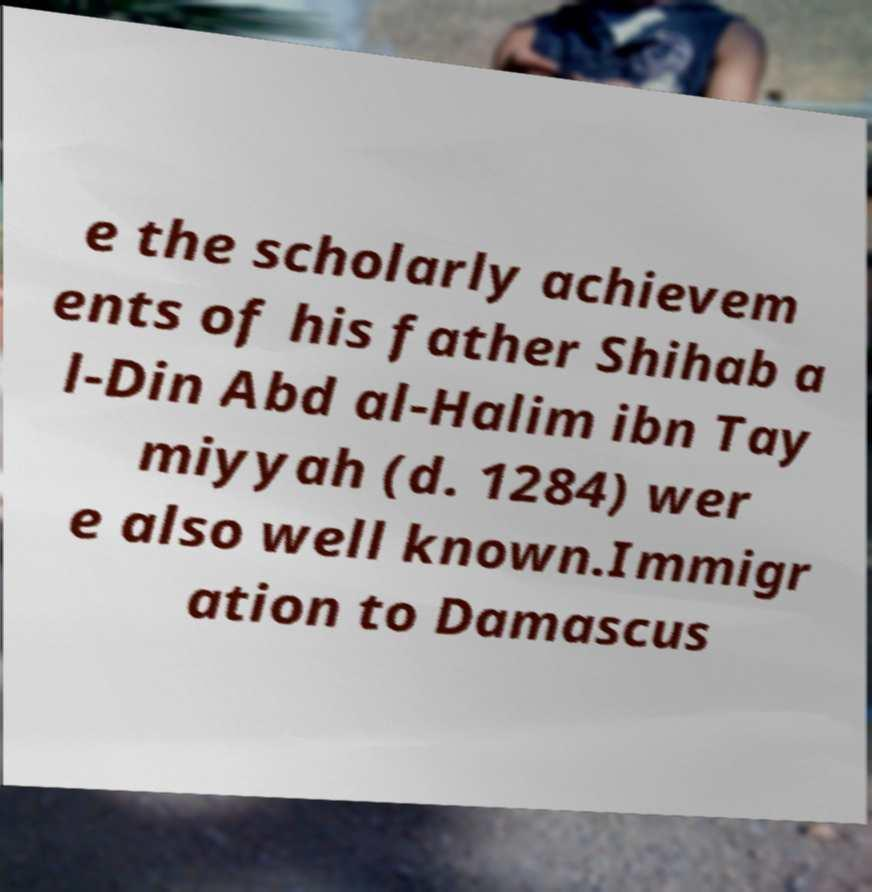Can you accurately transcribe the text from the provided image for me? e the scholarly achievem ents of his father Shihab a l-Din Abd al-Halim ibn Tay miyyah (d. 1284) wer e also well known.Immigr ation to Damascus 